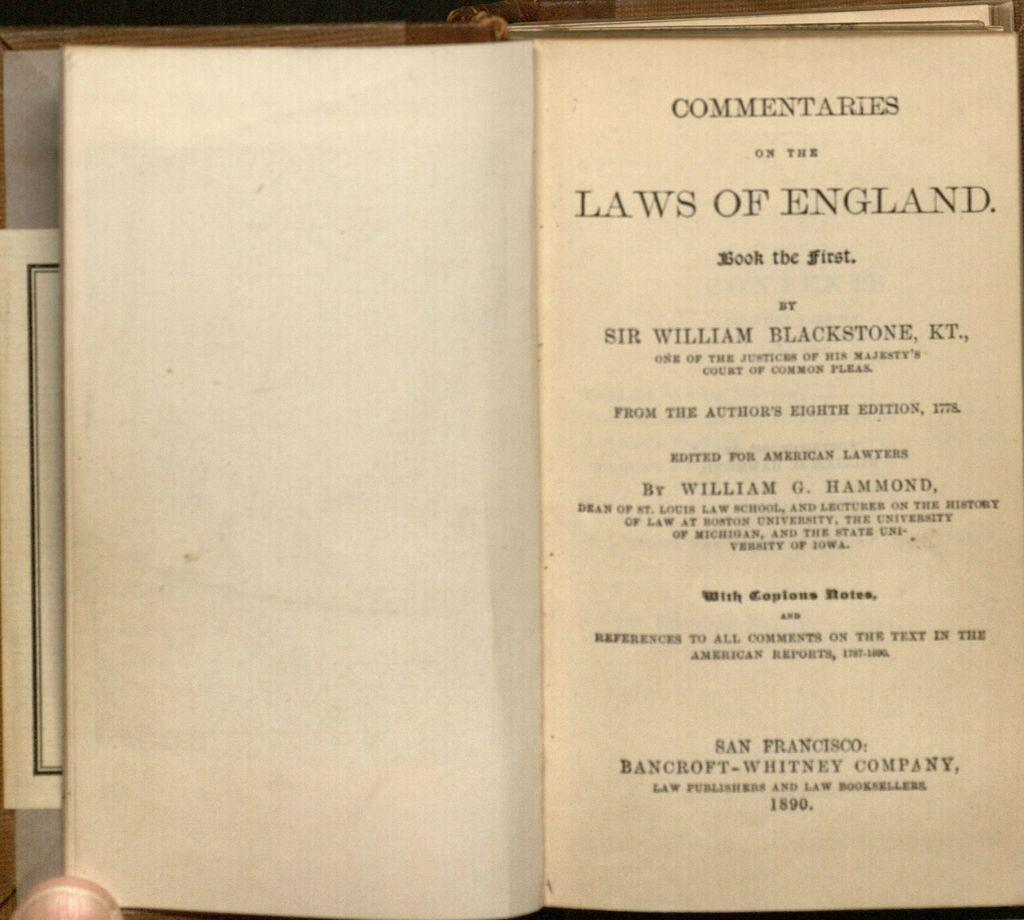<image>
Describe the image concisely. Laws of england commentaries chapter book by sir william blackstone 